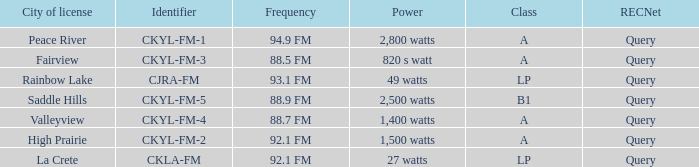What is the identifier with 94.9 fm frequency CKYL-FM-1. 